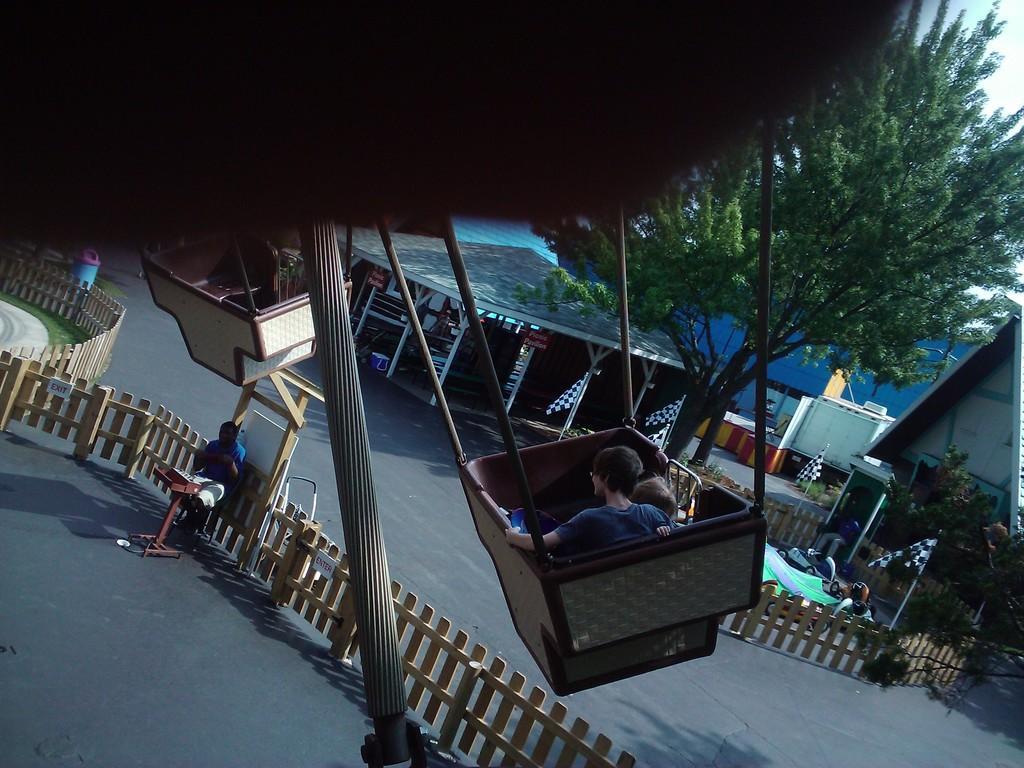Could you give a brief overview of what you see in this image? We can able to see a swings, inside this swings a persons are sitting. This is fence. These are tents. This is a tree in green color. Far there are flags. This person is sitting on a chair. 